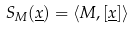Convert formula to latex. <formula><loc_0><loc_0><loc_500><loc_500>S _ { M } ( \underline { x } ) = \langle M , \left [ \underline { x } \right ] \rangle</formula> 